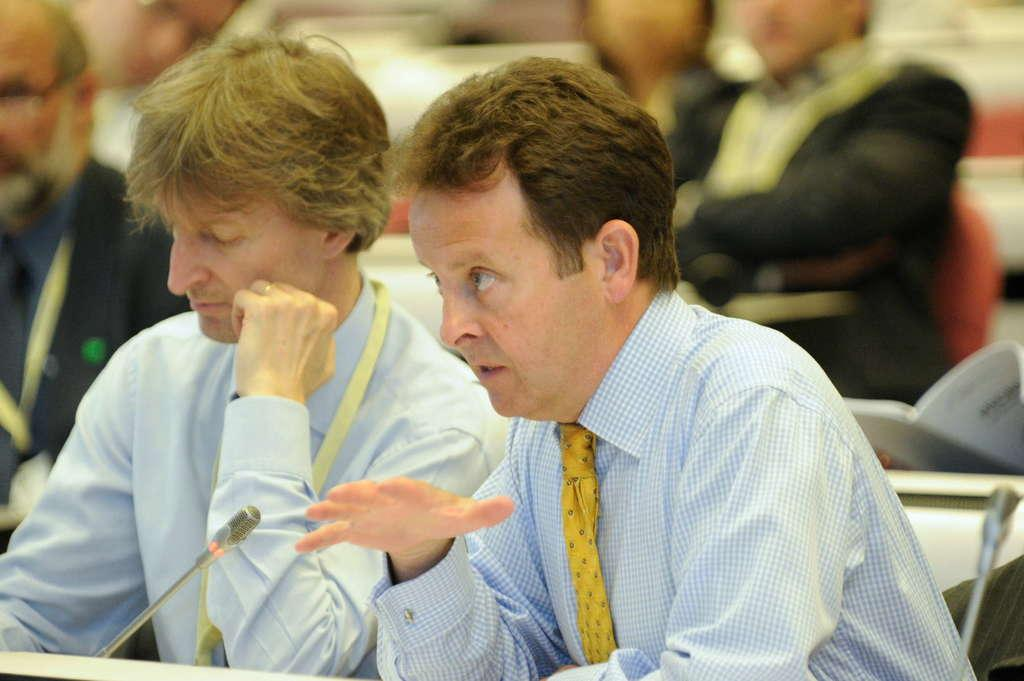How many people are in the image? There are persons in the image, but the exact number is not specified. What objects are present in the image that are used for amplifying sound? There are microphones in the image. What type of object can be seen that is typically used for reading or studying? There is a book in the image. Can you describe any other objects present in the image? There are other unspecified objects in the image. What type of celery is being used as a veil in the image? There is no celery or veil present in the image. How does the disgust in the image manifest itself? There is no indication of disgust in the image. 